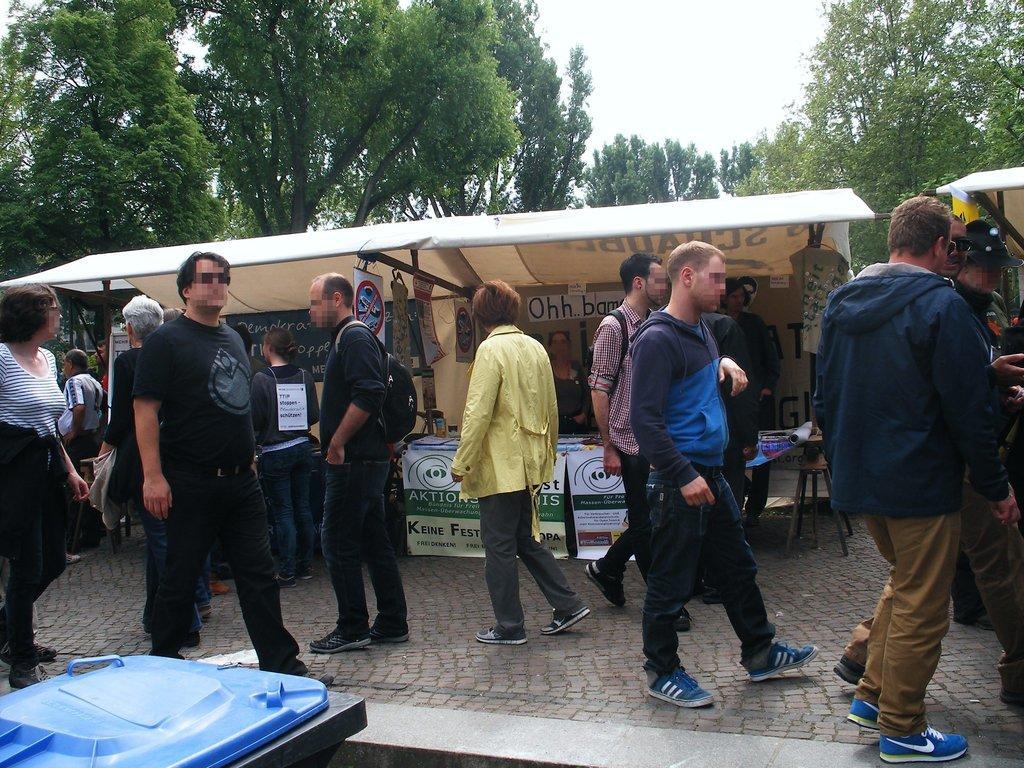Could you give a brief overview of what you see in this image? In this image we can see a few people, among them some are carrying bags, we can see there are some shops, boards, posters, trees and some other objects, in the background we can see the sky. 